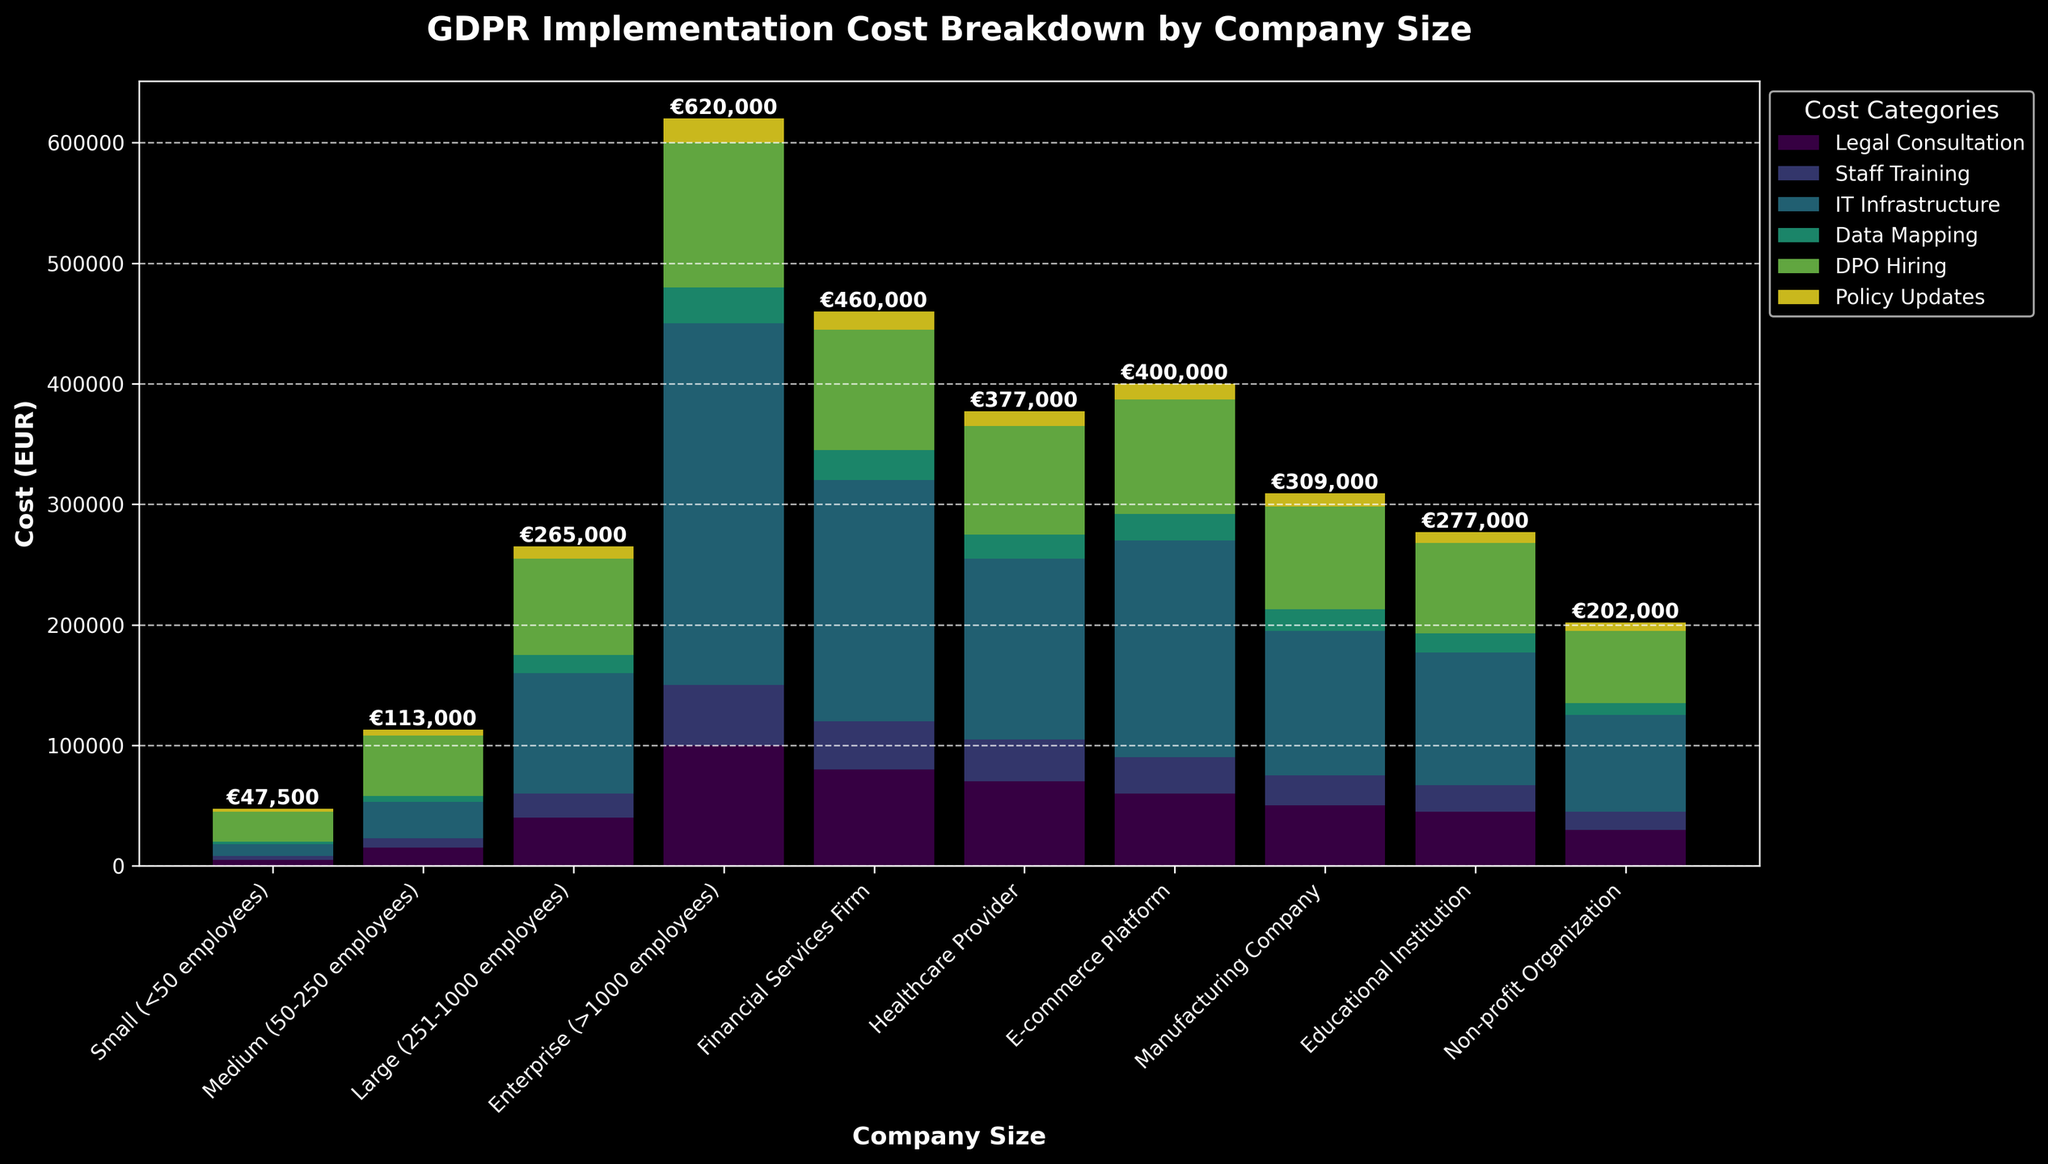What is the total cost for a Small (<50 employees) company to implement GDPR? The total cost for each company is displayed at the top of the corresponding bar. For a Small company, the total cost is displayed as €47,500.
Answer: €47,500 Which company size has the highest cost for IT Infrastructure? By visually comparing the bars, the Enterprise company size has the highest segment for IT Infrastructure.
Answer: Enterprise (>1000 employees) What is the difference in the total cost of GDPR implementation between a Large (251-1000 employees) company and a Medium (50-250 employees) company? The total cost for a Large company is €265,000, and for a Medium company, it is €113,000. The difference is €265,000 - €113,000 = €152,000.
Answer: €152,000 How does the cost of Staff Training in a Financial Services Firm compare to that in an E-commerce Platform? By visually comparing the Staff Training section in the bars of both categories, Financial Services Firm has a lower Staff Training cost (€40,000) compared to E-commerce Platform (€30,000).
Answer: Financial Services Firm is less by €10,000 What is the combined cost of Data Mapping and Policy Updates for a Healthcare Provider? The cost for Data Mapping is €20,000 and for Policy Updates is €12,000. Combined, €20,000 + €12,000 = €32,000.
Answer: €32,000 Which company type has the lowest cost for DPO Hiring? By visually comparing the DPO Hiring segments in the bars, Non-profit Organization has the lowest cost (€60,000) for DPO Hiring.
Answer: Non-profit Organization Among all the company sizes and types, which has the smallest cost segment, and what is the category? The smallest segment appears in the Small company size for Data Mapping, with a visual comparison showing it is the smallest.
Answer: Small (<50 employees) for Data Mapping How much more does an Enterprise company spend on Legal Consultation compared to a Non-profit Organization? The cost of Legal Consultation for an Enterprise company is €100,000 and for a Non-profit Organization, it is €30,000. The difference is €100,000 - €30,000 = €70,000.
Answer: €70,000 What is the average total cost for GDPR implementation among all company sizes and types listed? Summing up all the total costs mentioned: €47,500 + €113,000 + €265,000 + €620,000 + €460,000 + €377,000 + €400,000 + €309,000 + €277,000 + €202,000 = €3,070,500. There are 10 companies. The average is €3,070,500 / 10 = €307,050.
Answer: €307,050 